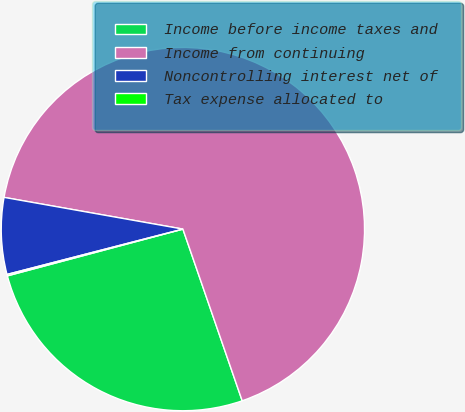Convert chart. <chart><loc_0><loc_0><loc_500><loc_500><pie_chart><fcel>Income before income taxes and<fcel>Income from continuing<fcel>Noncontrolling interest net of<fcel>Tax expense allocated to<nl><fcel>26.15%<fcel>66.92%<fcel>6.81%<fcel>0.13%<nl></chart> 